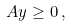<formula> <loc_0><loc_0><loc_500><loc_500>A y \geq 0 \, ,</formula> 